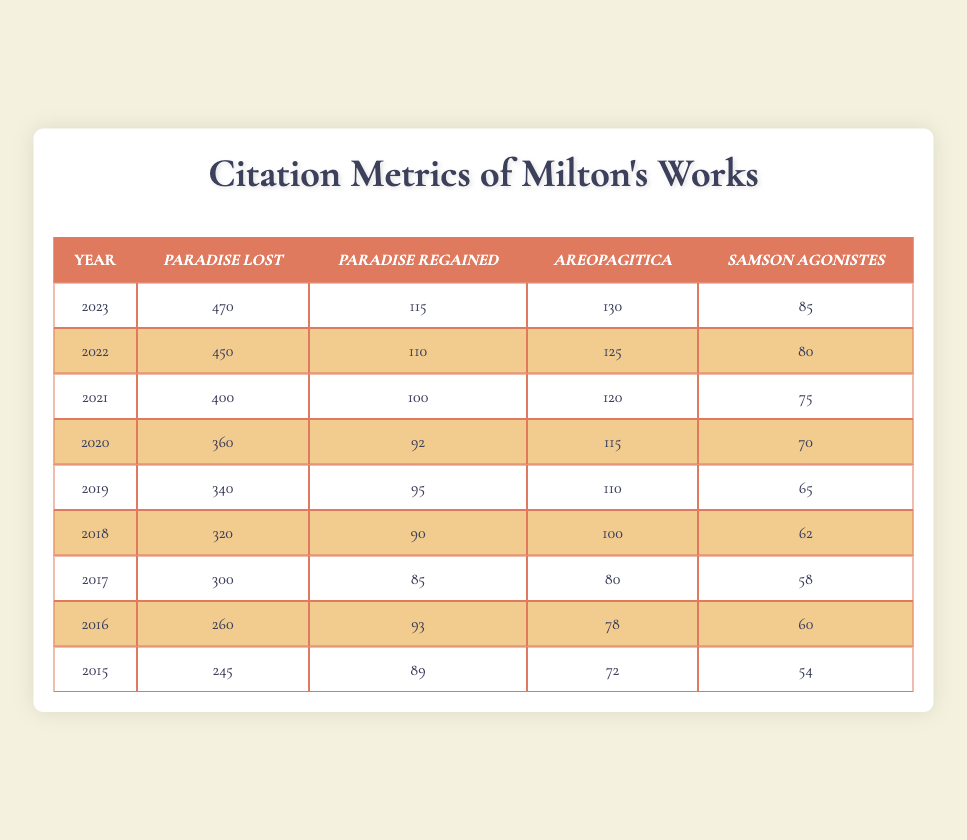What is the total number of citations for "Areopagitica" in 2022? The table shows that "Areopagitica" had 125 citations in 2022.
Answer: 125 Which year saw the highest citations for "Paradise Lost"? Looking through the years, "Paradise Lost" had its highest citations in 2023, with 470 citations.
Answer: 2023 What is the average number of citations for "Samson Agonistes" from 2015 to 2023? The total citations for "Samson Agonistes" from 2015 to 2023 are (54 + 60 + 58 + 62 + 65 + 70 + 75 + 80 + 85) =  675. There are 9 years, so the average is 675/9 = 75.
Answer: 75 Did "Paradise Regained" have more citations in 2021 than in 2015? In 2021, "Paradise Regained" had 100 citations, and in 2015 it had 89 citations. Since 100 is greater than 89, the statement is true.
Answer: Yes What is the increase in citations for "Areopagitica" from 2015 to 2023? In 2015, "Areopagitica" had 72 citations and in 2023 it had 130 citations. The increase is 130 - 72 = 58 citations.
Answer: 58 